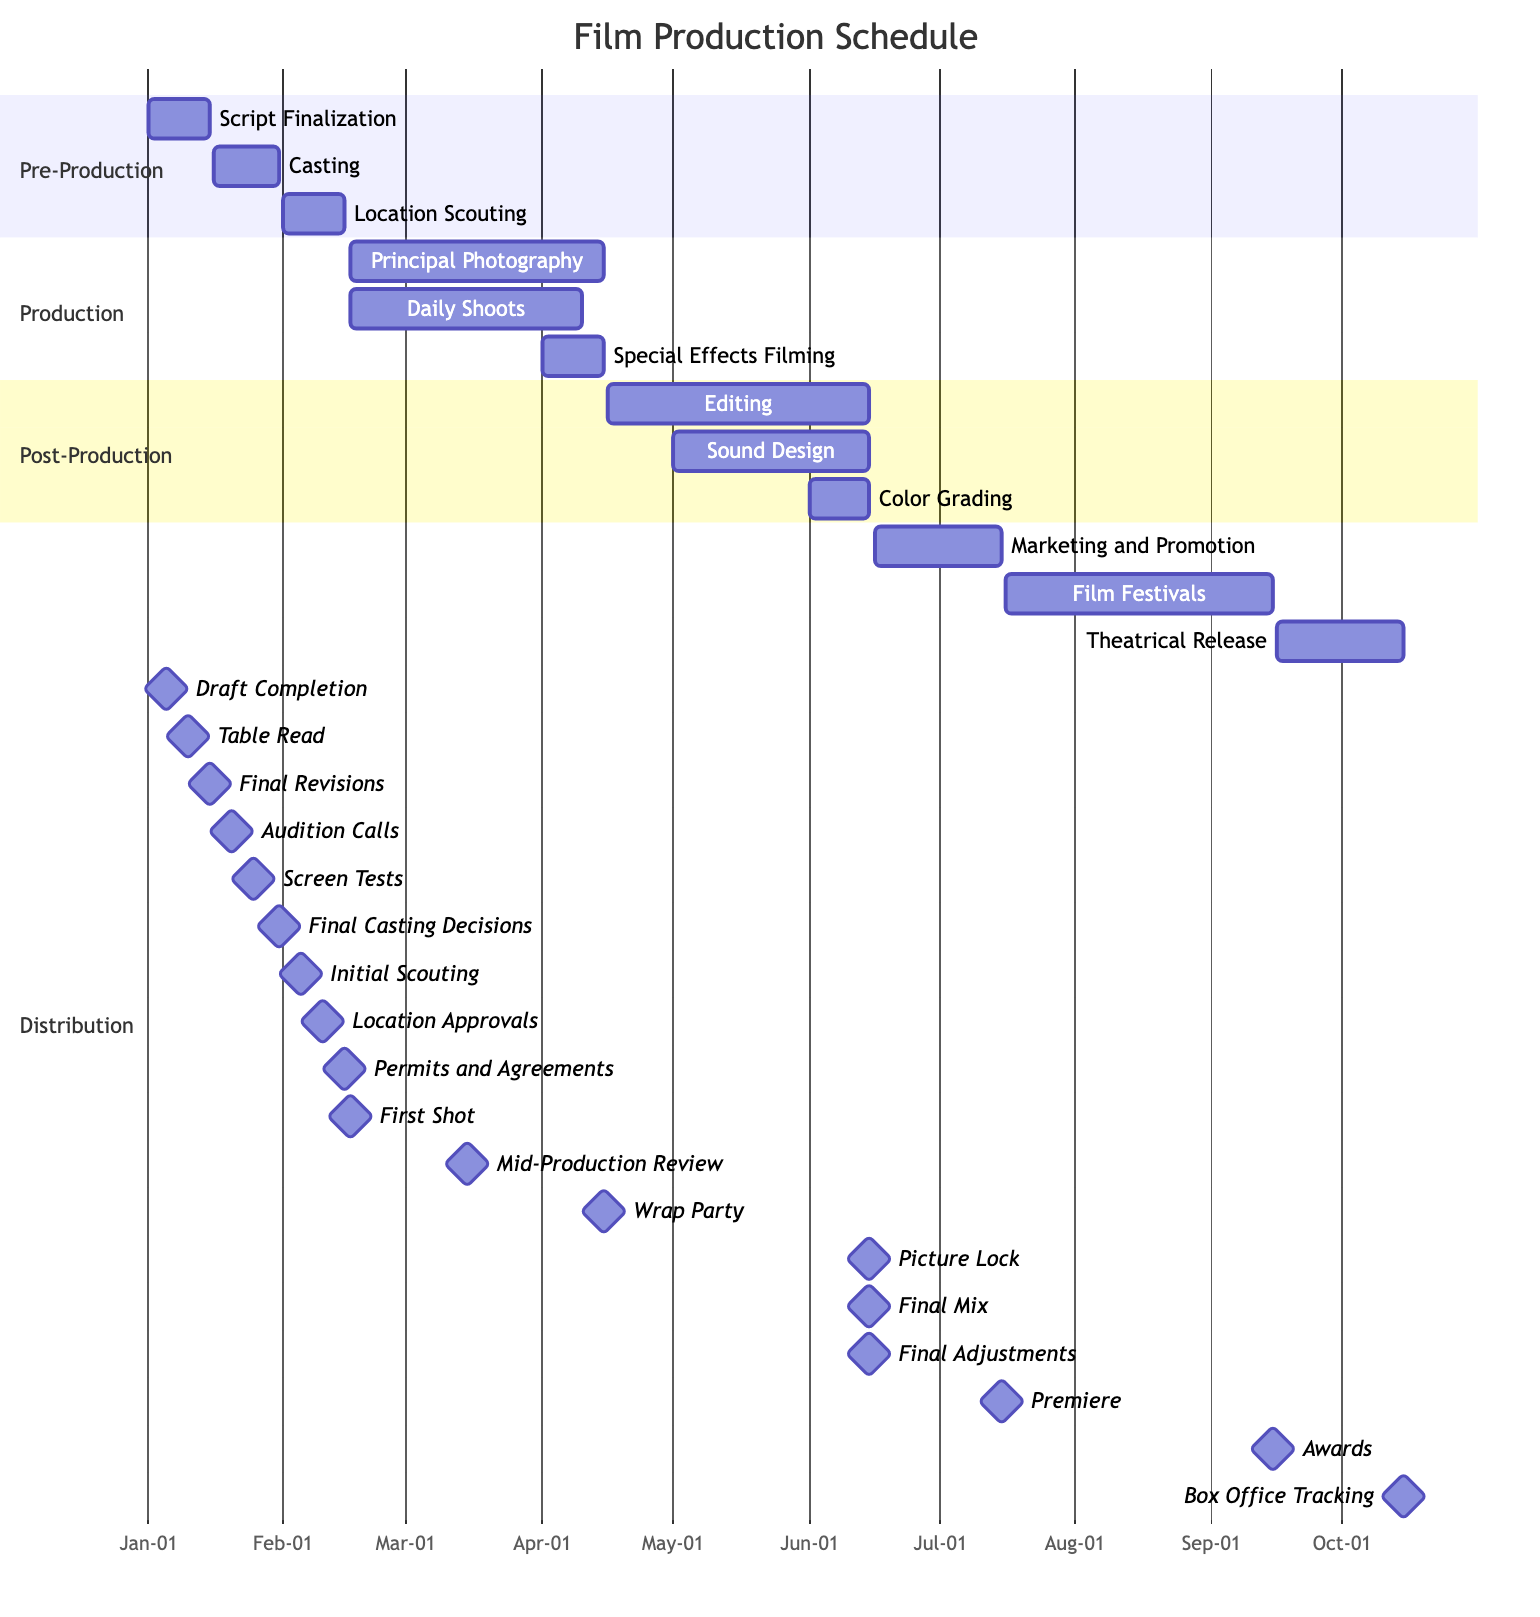What is the duration of the Pre-Production phase? The Pre-Production phase starts on January 1, 2023, and ends on February 15, 2023. Calculating the duration gives us a total of 46 days.
Answer: 46 days What task immediately follows Location Scouting? Looking at the diagram, after Location Scouting ends on February 15, 2023, the next task that starts is Principal Photography on February 16, 2023.
Answer: Principal Photography How many milestones are associated with Sound Design? The Sound Design task has three listed milestones: Sound Effects, Dialogue Editing, and Final Mix. Counting these gives us a total of three milestones.
Answer: 3 What is the ending date of the Editing task? The Editing task starts on April 16, 2023, and ends on June 15, 2023, as indicated in the diagram. Thus, the ending date is June 15, 2023.
Answer: June 15, 2023 Which section contains the task 'Casting'? The task 'Casting' is found within the Pre-Production section of the Gantt chart, as denoted by the organized segments.
Answer: Pre-Production During which timeframe do the Daily Shoots occur? The Daily Shoots task begins on February 16, 2023, and concludes on April 10, 2023, as illustrated in the diagram.
Answer: February 16, 2023 to April 10, 2023 What is the relationship between the Principal Photography task and the Special Effects Filming task? The Principal Photography task overlaps with the Special Effects Filming task from April 1, 2023, to April 15, 2023. Both tasks are active during this window, demonstrating a collaborative period.
Answer: Overlapping How many total tasks are included in the Post-Production section? In the Post-Production section, there are three tasks listed: Editing, Sound Design, and Color Grading. Counting these gives us three tasks total.
Answer: 3 What is the milestone associated with the first day of Principal Photography? The first day of Principal Photography, February 16, 2023, has the milestone labeled as First Shot. Therefore, the associated milestone is First Shot.
Answer: First Shot 